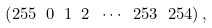Convert formula to latex. <formula><loc_0><loc_0><loc_500><loc_500>\left ( 2 5 5 \ 0 \ 1 \ 2 \ \cdots \ 2 5 3 \ 2 5 4 \right ) ,</formula> 